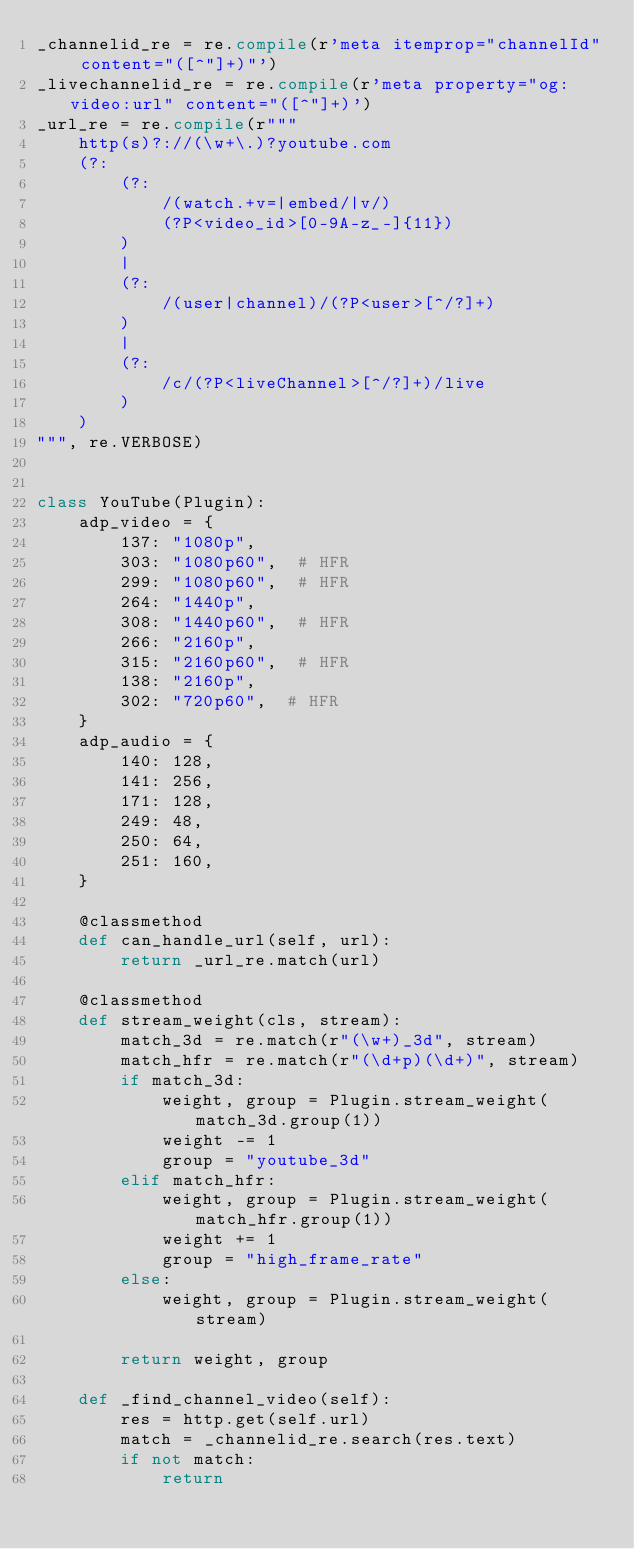<code> <loc_0><loc_0><loc_500><loc_500><_Python_>_channelid_re = re.compile(r'meta itemprop="channelId" content="([^"]+)"')
_livechannelid_re = re.compile(r'meta property="og:video:url" content="([^"]+)')
_url_re = re.compile(r"""
    http(s)?://(\w+\.)?youtube.com
    (?:
        (?:
            /(watch.+v=|embed/|v/)
            (?P<video_id>[0-9A-z_-]{11})
        )
        |
        (?:
            /(user|channel)/(?P<user>[^/?]+)
        )
        |
        (?:
            /c/(?P<liveChannel>[^/?]+)/live
        )
    )
""", re.VERBOSE)


class YouTube(Plugin):
    adp_video = {
        137: "1080p",
        303: "1080p60",  # HFR
        299: "1080p60",  # HFR
        264: "1440p",
        308: "1440p60",  # HFR
        266: "2160p",
        315: "2160p60",  # HFR
        138: "2160p",
        302: "720p60",  # HFR
    }
    adp_audio = {
        140: 128,
        141: 256,
        171: 128,
        249: 48,
        250: 64,
        251: 160,
    }

    @classmethod
    def can_handle_url(self, url):
        return _url_re.match(url)

    @classmethod
    def stream_weight(cls, stream):
        match_3d = re.match(r"(\w+)_3d", stream)
        match_hfr = re.match(r"(\d+p)(\d+)", stream)
        if match_3d:
            weight, group = Plugin.stream_weight(match_3d.group(1))
            weight -= 1
            group = "youtube_3d"
        elif match_hfr:
            weight, group = Plugin.stream_weight(match_hfr.group(1))
            weight += 1
            group = "high_frame_rate"
        else:
            weight, group = Plugin.stream_weight(stream)

        return weight, group

    def _find_channel_video(self):
        res = http.get(self.url)
        match = _channelid_re.search(res.text)
        if not match:
            return
</code> 